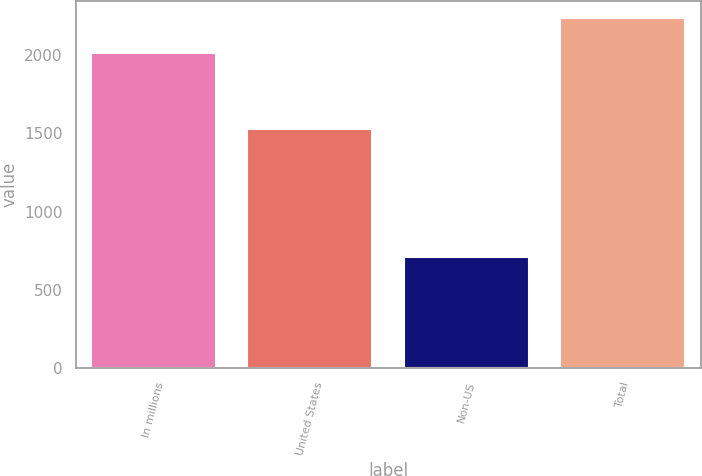<chart> <loc_0><loc_0><loc_500><loc_500><bar_chart><fcel>In millions<fcel>United States<fcel>Non-US<fcel>Total<nl><fcel>2016<fcel>1531.2<fcel>706.8<fcel>2238<nl></chart> 